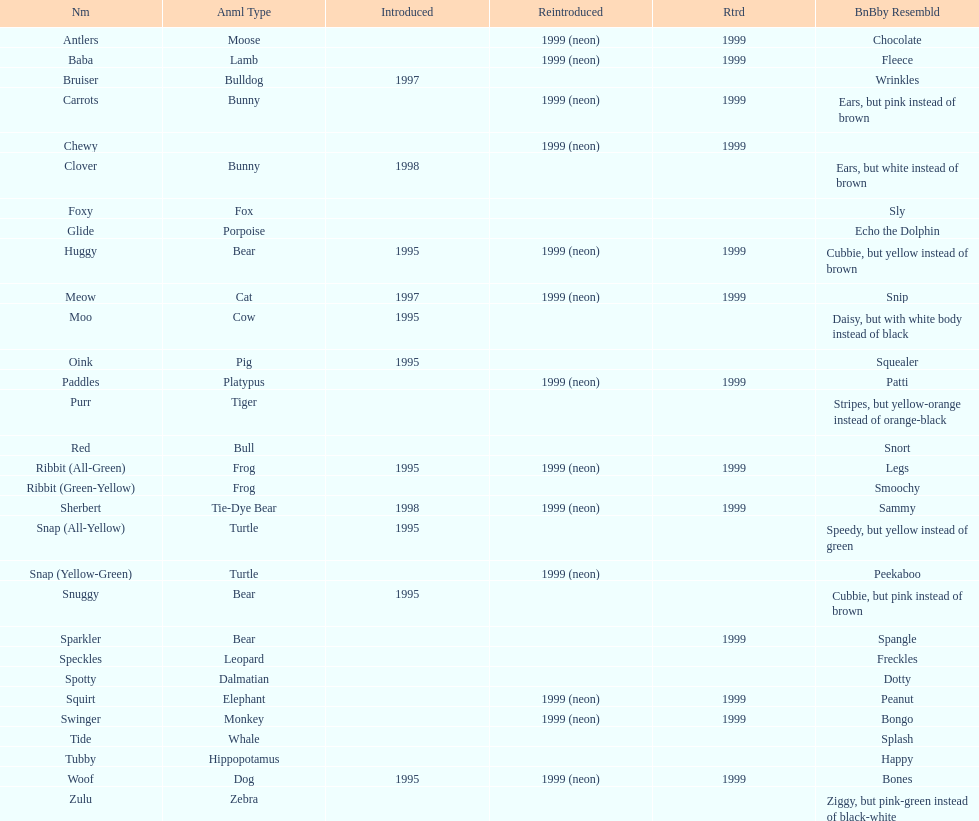Which is the only pillow pal without a listed animal type? Chewy. 